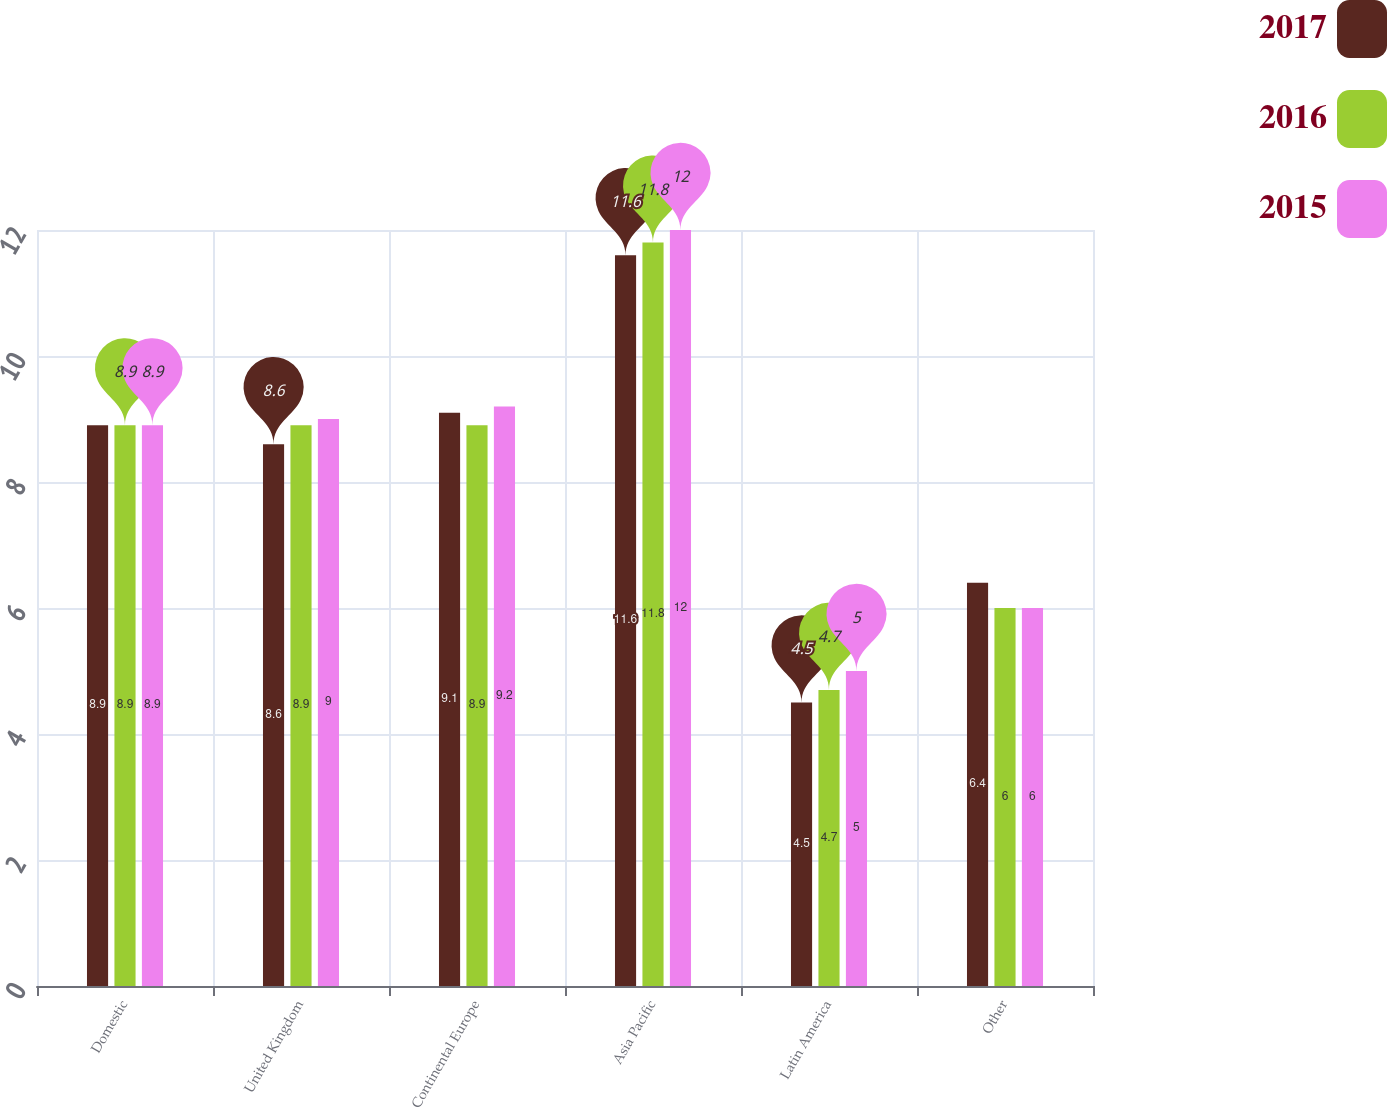<chart> <loc_0><loc_0><loc_500><loc_500><stacked_bar_chart><ecel><fcel>Domestic<fcel>United Kingdom<fcel>Continental Europe<fcel>Asia Pacific<fcel>Latin America<fcel>Other<nl><fcel>2017<fcel>8.9<fcel>8.6<fcel>9.1<fcel>11.6<fcel>4.5<fcel>6.4<nl><fcel>2016<fcel>8.9<fcel>8.9<fcel>8.9<fcel>11.8<fcel>4.7<fcel>6<nl><fcel>2015<fcel>8.9<fcel>9<fcel>9.2<fcel>12<fcel>5<fcel>6<nl></chart> 